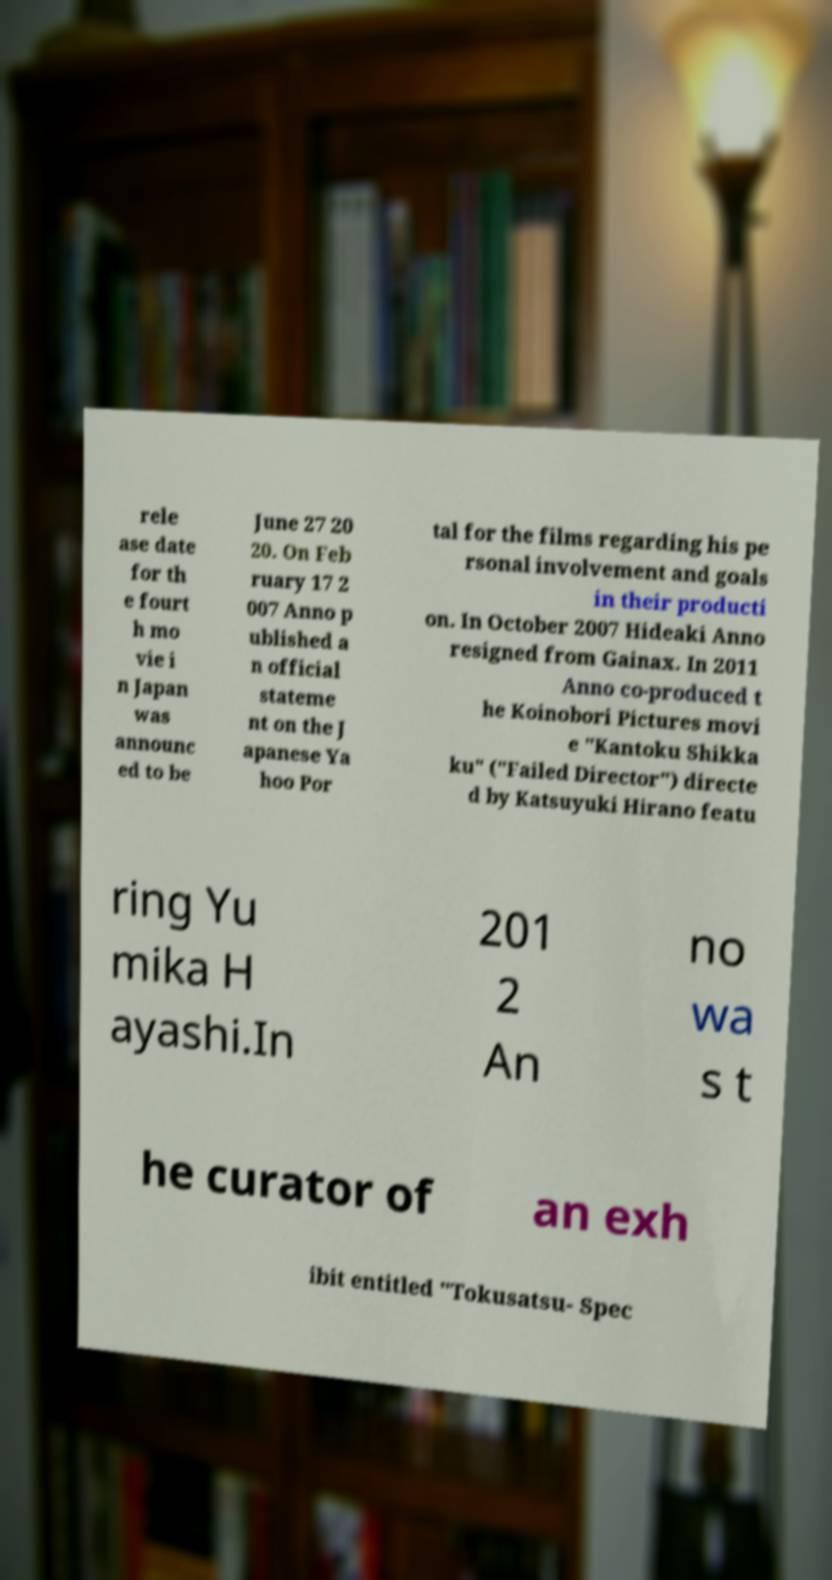For documentation purposes, I need the text within this image transcribed. Could you provide that? rele ase date for th e fourt h mo vie i n Japan was announc ed to be June 27 20 20. On Feb ruary 17 2 007 Anno p ublished a n official stateme nt on the J apanese Ya hoo Por tal for the films regarding his pe rsonal involvement and goals in their producti on. In October 2007 Hideaki Anno resigned from Gainax. In 2011 Anno co-produced t he Koinobori Pictures movi e "Kantoku Shikka ku" ("Failed Director") directe d by Katsuyuki Hirano featu ring Yu mika H ayashi.In 201 2 An no wa s t he curator of an exh ibit entitled "Tokusatsu- Spec 